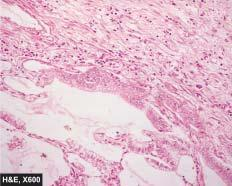what are the alveolar walls lined by?
Answer the question using a single word or phrase. Cuboidal to tall columnar and mucin-secreting tumour cells with papillary growth pattern 